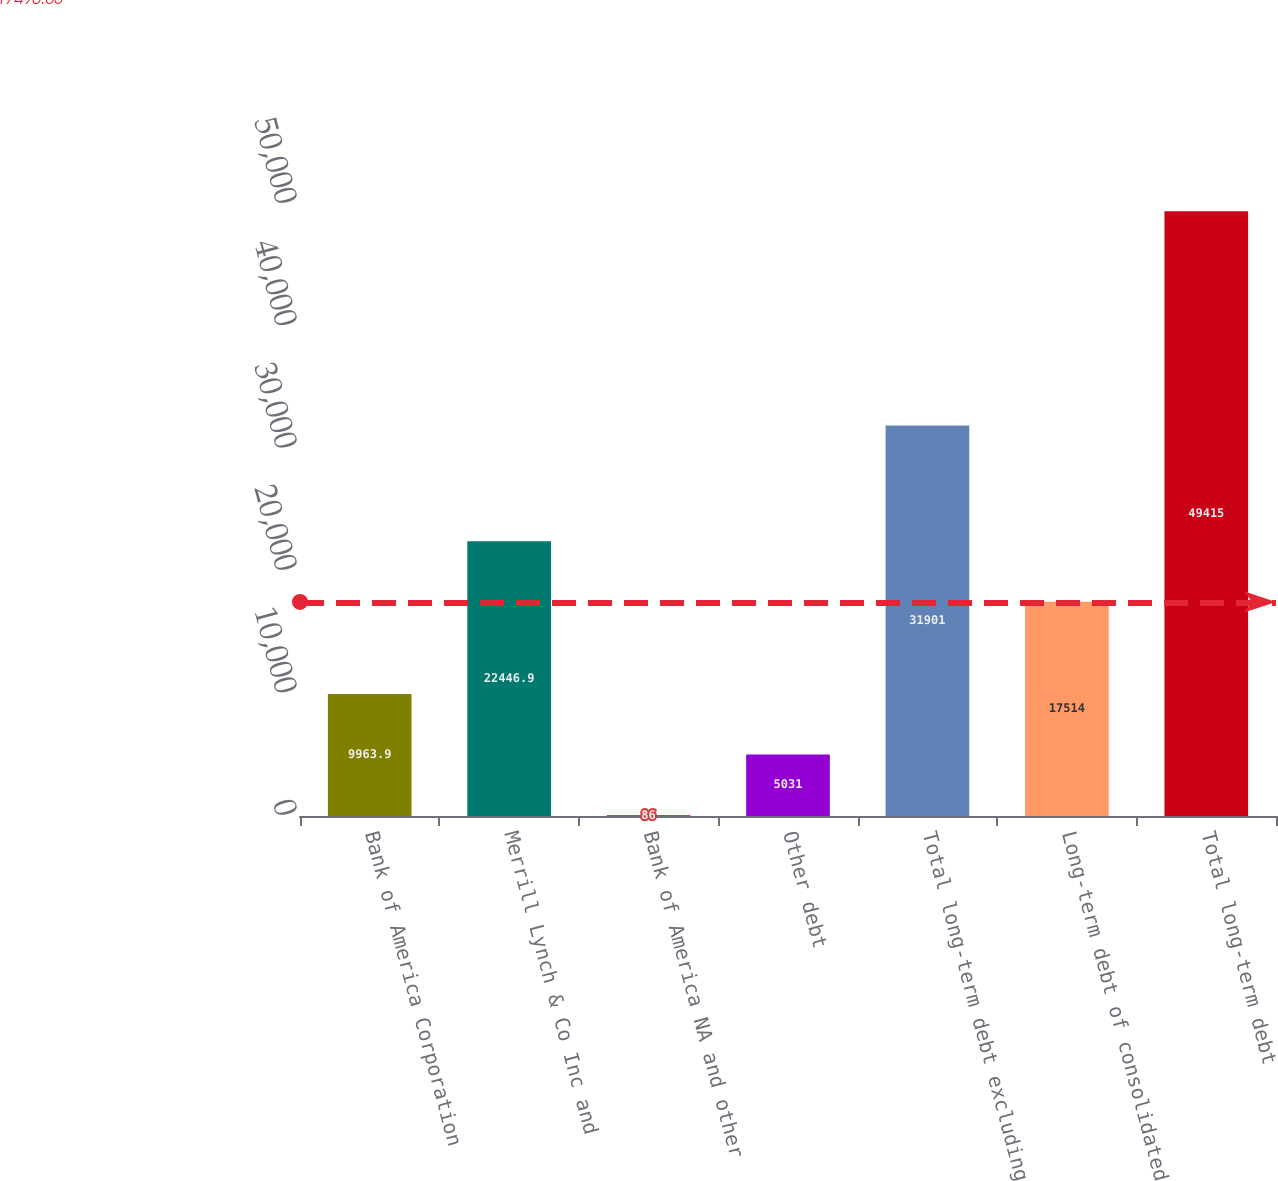Convert chart. <chart><loc_0><loc_0><loc_500><loc_500><bar_chart><fcel>Bank of America Corporation<fcel>Merrill Lynch & Co Inc and<fcel>Bank of America NA and other<fcel>Other debt<fcel>Total long-term debt excluding<fcel>Long-term debt of consolidated<fcel>Total long-term debt<nl><fcel>9963.9<fcel>22446.9<fcel>86<fcel>5031<fcel>31901<fcel>17514<fcel>49415<nl></chart> 